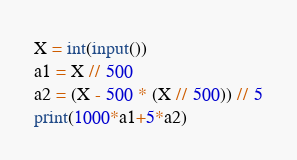<code> <loc_0><loc_0><loc_500><loc_500><_Python_>X = int(input())
a1 = X // 500
a2 = (X - 500 * (X // 500)) // 5
print(1000*a1+5*a2)</code> 